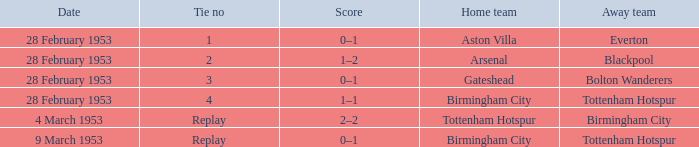Which Score has a Date of 28 february 1953, and a Tie no of 3? 0–1. 